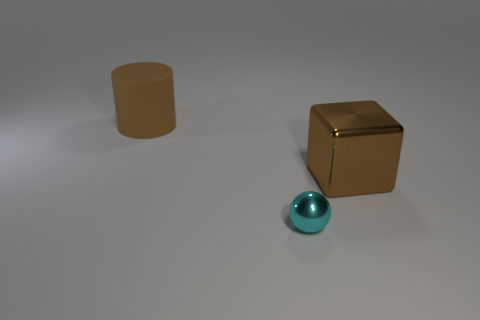What number of other things are the same shape as the cyan thing?
Provide a succinct answer. 0. Are any large brown cylinders visible?
Give a very brief answer. Yes. What number of things are either big red rubber blocks or brown things right of the big matte thing?
Your response must be concise. 1. There is a brown block that is behind the ball; does it have the same size as the sphere?
Provide a succinct answer. No. How many other things are there of the same size as the cyan ball?
Your answer should be very brief. 0. The rubber thing is what color?
Offer a terse response. Brown. What is the material of the big brown thing right of the small cyan object?
Offer a terse response. Metal. Is the number of big metal things left of the brown shiny thing the same as the number of rubber objects?
Keep it short and to the point. No. Does the brown rubber thing have the same shape as the small thing?
Your response must be concise. No. Is there anything else that is the same color as the big shiny thing?
Offer a terse response. Yes. 